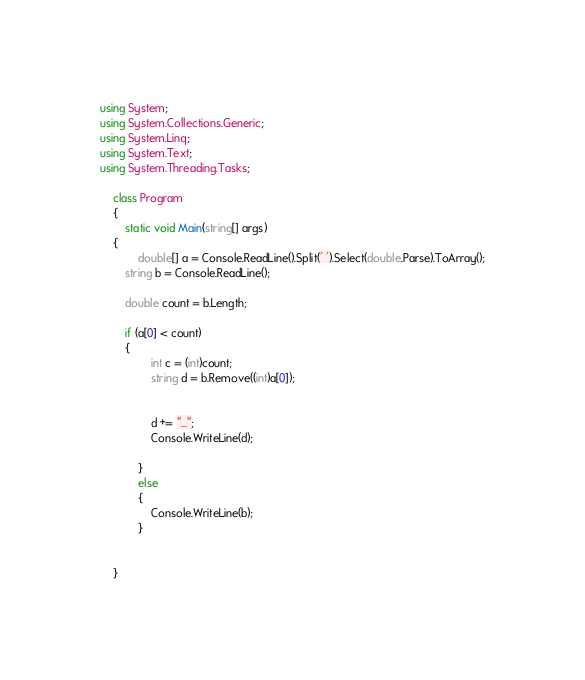<code> <loc_0><loc_0><loc_500><loc_500><_C#_>using System;
using System.Collections.Generic;
using System.Linq;
using System.Text;
using System.Threading.Tasks;

    class Program
    {
        static void Main(string[] args)
    {
            double[] a = Console.ReadLine().Split(' ').Select(double.Parse).ToArray();
        string b = Console.ReadLine();

        double count = b.Length;

        if (a[0] < count)
        {
                int c = (int)count;
                string d = b.Remove((int)a[0]);
                

                d += "...";
                Console.WriteLine(d);

            }
            else
            {
                Console.WriteLine(b);
            }
        

    }</code> 